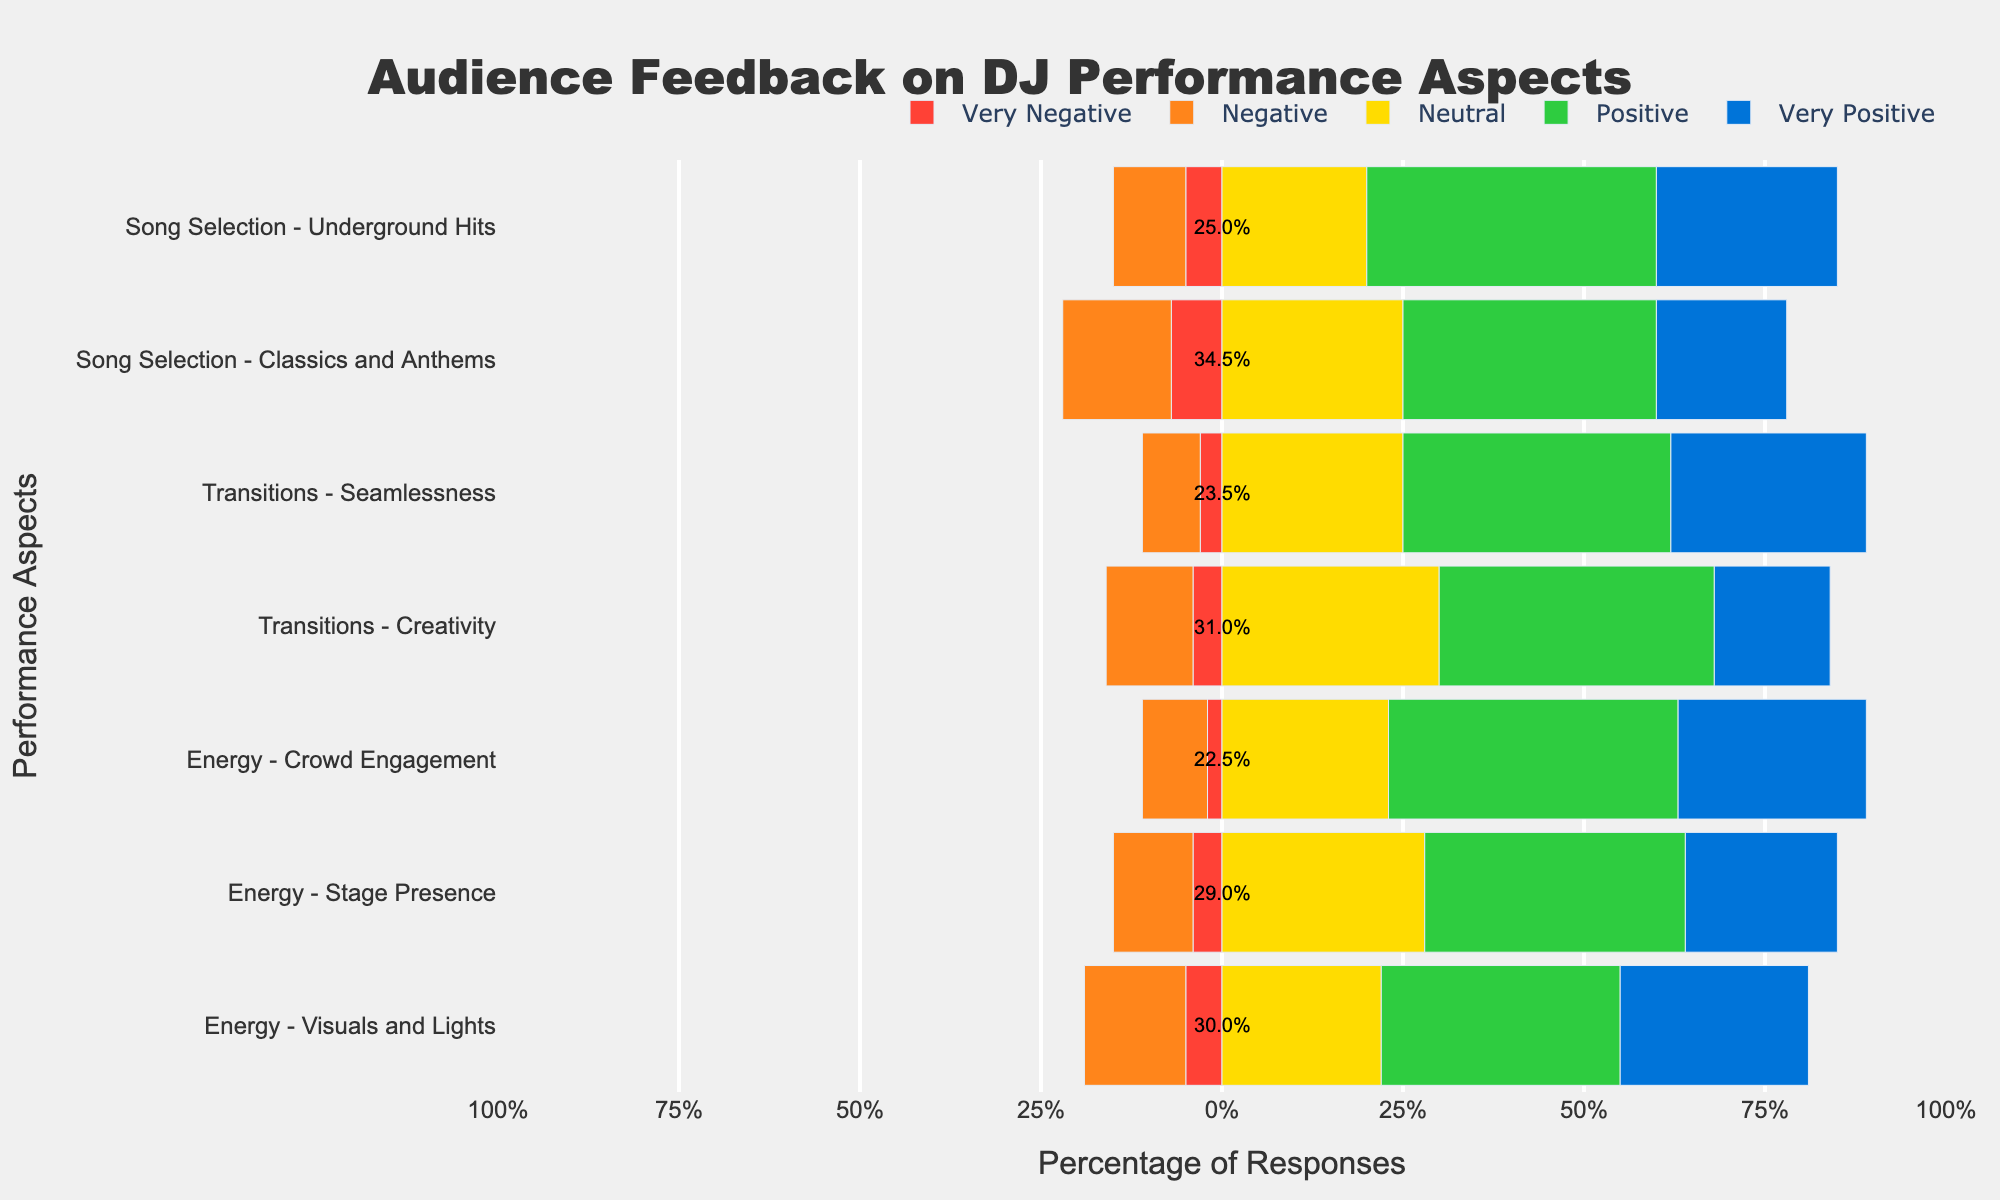What aspect received the highest percentage of 'Very Positive' feedback? To find this, look for the bar segment in dark blue (representing 'Very Positive') that is the longest. By comparing the lengths of these segments across all performance aspects, 'Crowd Engagement' under 'Energy' stands out as having the tallest dark blue section.
Answer: 'Crowd Engagement' under 'Energy' What's the difference in 'Very Positive' feedback between 'Seamlessness' and 'Visuals and Lights'? For 'Seamlessness' under 'Transitions', the percentage of 'Very Positive' feedback is 27%, while for 'Visuals and Lights' under 'Energy', it is 26%. Subtract the two values: 27% - 26% = 1%.
Answer: 1% Which criteria has the most equal distribution of feedback across all categories? To determine this, observe the bars that have segments of roughly equal lengths for all categories. 'Classics and Anthems' under 'Song Selection' appears to have the most balanced bar with smaller differences between segments.
Answer: 'Classics and Anthems' under 'Song Selection' What is the total percentage of positive feedback (combining 'Positive' and 'Very Positive') for 'Creativity' in 'Transitions'? 'Creativity' under 'Transitions' has 38% 'Positive' and 16% 'Very Positive'. Sum these values: 38% + 16% = 54%.
Answer: 54% How does the 'Neutral' feedback for 'Stage Presence' compare to 'Crowd Engagement'? For 'Stage Presence' under 'Energy', 'Neutral' feedback is 28%, and for 'Crowd Engagement' under 'Energy', it is 23%. Comparing these, 'Stage Presence' has a higher percentage of 'Neutral' feedback.
Answer: 'Stage Presence' has more What is the cumulative percentage of negative feedback ('Very Negative' and 'Negative') for 'Underground Hits'? 'Underground Hits' under 'Song Selection' has 5% 'Very Negative' and 10% 'Negative'. Summing these values gives: 5% + 10% = 15%.
Answer: 15% Which aspect under 'Transitions' received the most 'Neutral' feedback? Compare the yellow segments representing 'Neutral' feedback for 'Seamlessness' and 'Creativity'. 'Creativity' has a higher 'Neutral' percentage at 30%, compared to 'Seamlessness' at 25%.
Answer: 'Creativity' Is the positive feedback for 'Song Selection' aspects higher than the respective negative feedback? For 'Underground Hits', positive feedback (40% + 25% = 65%) is higher than negative feedback (5% + 10% = 15%). Similarly, for 'Classics and Anthems', positive feedback (35% + 18% = 53%) is greater than negative feedback (7% + 15% = 22%).
Answer: Yes What's the sum of 'Very Positive' feedback for all 'Energy' criteria? Sum the 'Very Positive' feedback percentages for 'Crowd Engagement' (26%), 'Stage Presence' (21%), and 'Visuals and Lights' (26%). Adding up these values gives: 26% + 21% + 26% = 73%.
Answer: 73% 